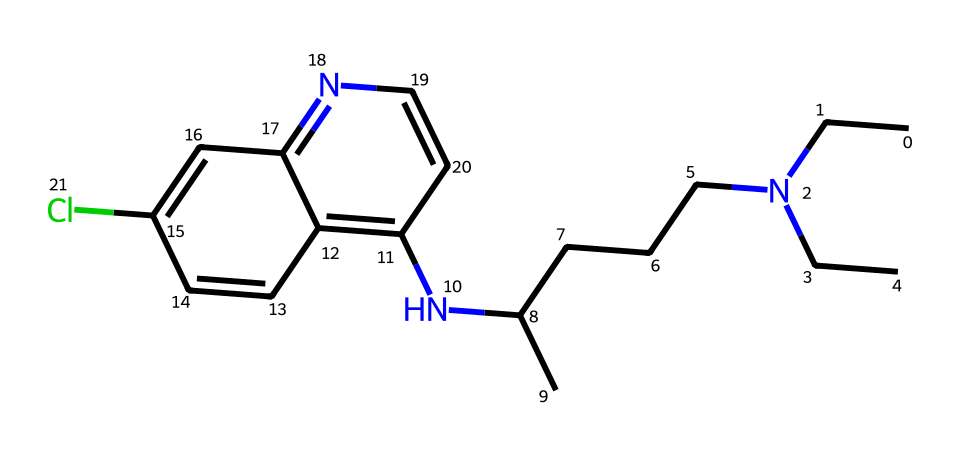What is the molecular formula of chloroquine? To find the molecular formula, we need to identify all the atoms in the SMILES representation and count them. By analyzing the structure represented by the SMILES, we can determine that there are 18 Carbon (C) atoms, 22 Hydrogen (H) atoms, 2 Nitrogen (N) atoms, and 1 Chlorine (Cl) atom. Therefore, the molecular formula can be summarized as C18H22ClN3.
Answer: C18H22ClN3 How many chiral centers are in chloroquine? Chloroquine has two chiral centers in its structure. A chiral center is typically defined by a carbon atom that is bonded to four different substituents, which can be identified in the three-dimensional representation. By examining the chemical structure, both centers are revealed.
Answer: 2 What class of compounds does chloroquine belong to? Chloroquine is classified as an alkaloid due to its nitrogen-containing heterocycles, which are typical of this class. The nitrogen atoms in the structure contribute to its biological activity and medicinal properties, characteristic of alkaloids.
Answer: alkaloid What is the significance of stereochemistry in chloroquine? The stereochemistry of chloroquine is significant because its two enantiomers have different biological activities. One enantiomer is effective against malaria, while the other may not exhibit the same therapeutic effects. Understanding the stereochemistry allows for more effective drug design and usage.
Answer: biological activity What is the primary use of chloroquine? Chloroquine is primarily used as an antimalarial drug. It has been traditionally used to prevent and treat malaria, particularly caused by Plasmodium falciparum, which is a major reason for its clinical relevance.
Answer: antimalarial 